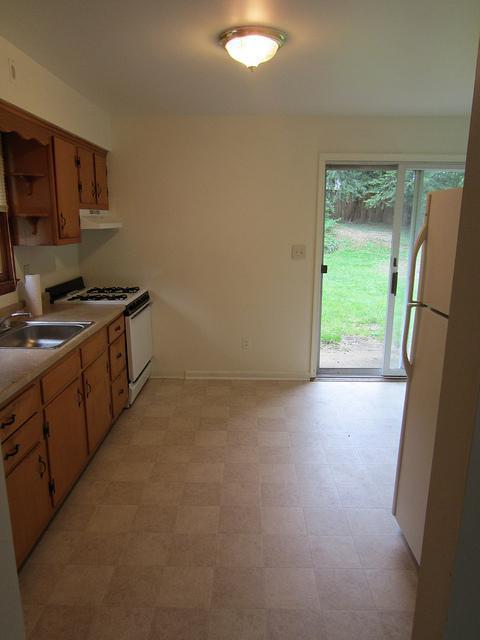How many doorways are pictured in the room?
Give a very brief answer. 1. How many lights can be seen?
Give a very brief answer. 1. How many people are sitting on the bench?
Give a very brief answer. 0. 